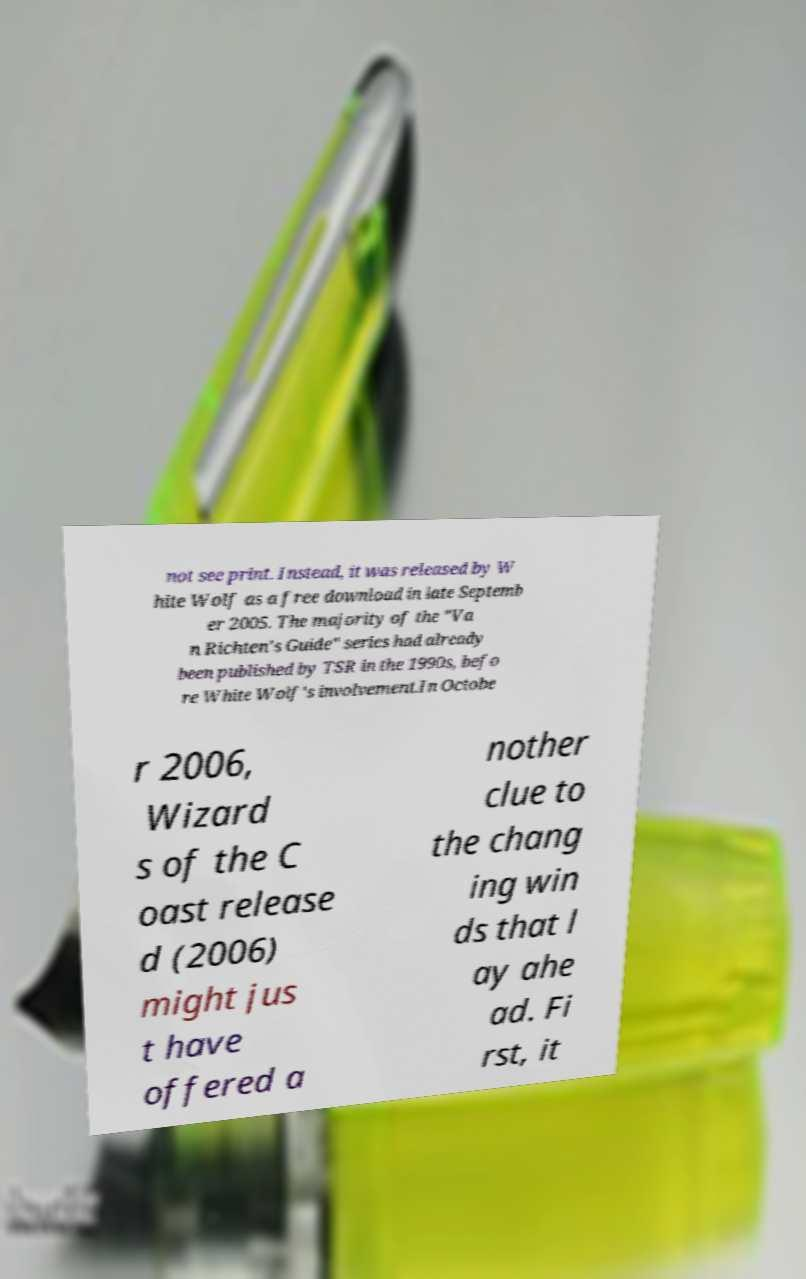There's text embedded in this image that I need extracted. Can you transcribe it verbatim? not see print. Instead, it was released by W hite Wolf as a free download in late Septemb er 2005. The majority of the "Va n Richten's Guide" series had already been published by TSR in the 1990s, befo re White Wolf's involvement.In Octobe r 2006, Wizard s of the C oast release d (2006) might jus t have offered a nother clue to the chang ing win ds that l ay ahe ad. Fi rst, it 